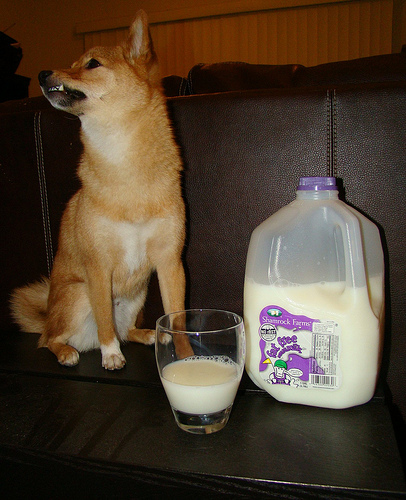<image>
Is the dog behind the milk? Yes. From this viewpoint, the dog is positioned behind the milk, with the milk partially or fully occluding the dog. Where is the sofa in relation to the dog? Is it behind the dog? Yes. From this viewpoint, the sofa is positioned behind the dog, with the dog partially or fully occluding the sofa. Is the milk behind the label? Yes. From this viewpoint, the milk is positioned behind the label, with the label partially or fully occluding the milk. Is the dog in the glass? No. The dog is not contained within the glass. These objects have a different spatial relationship. 